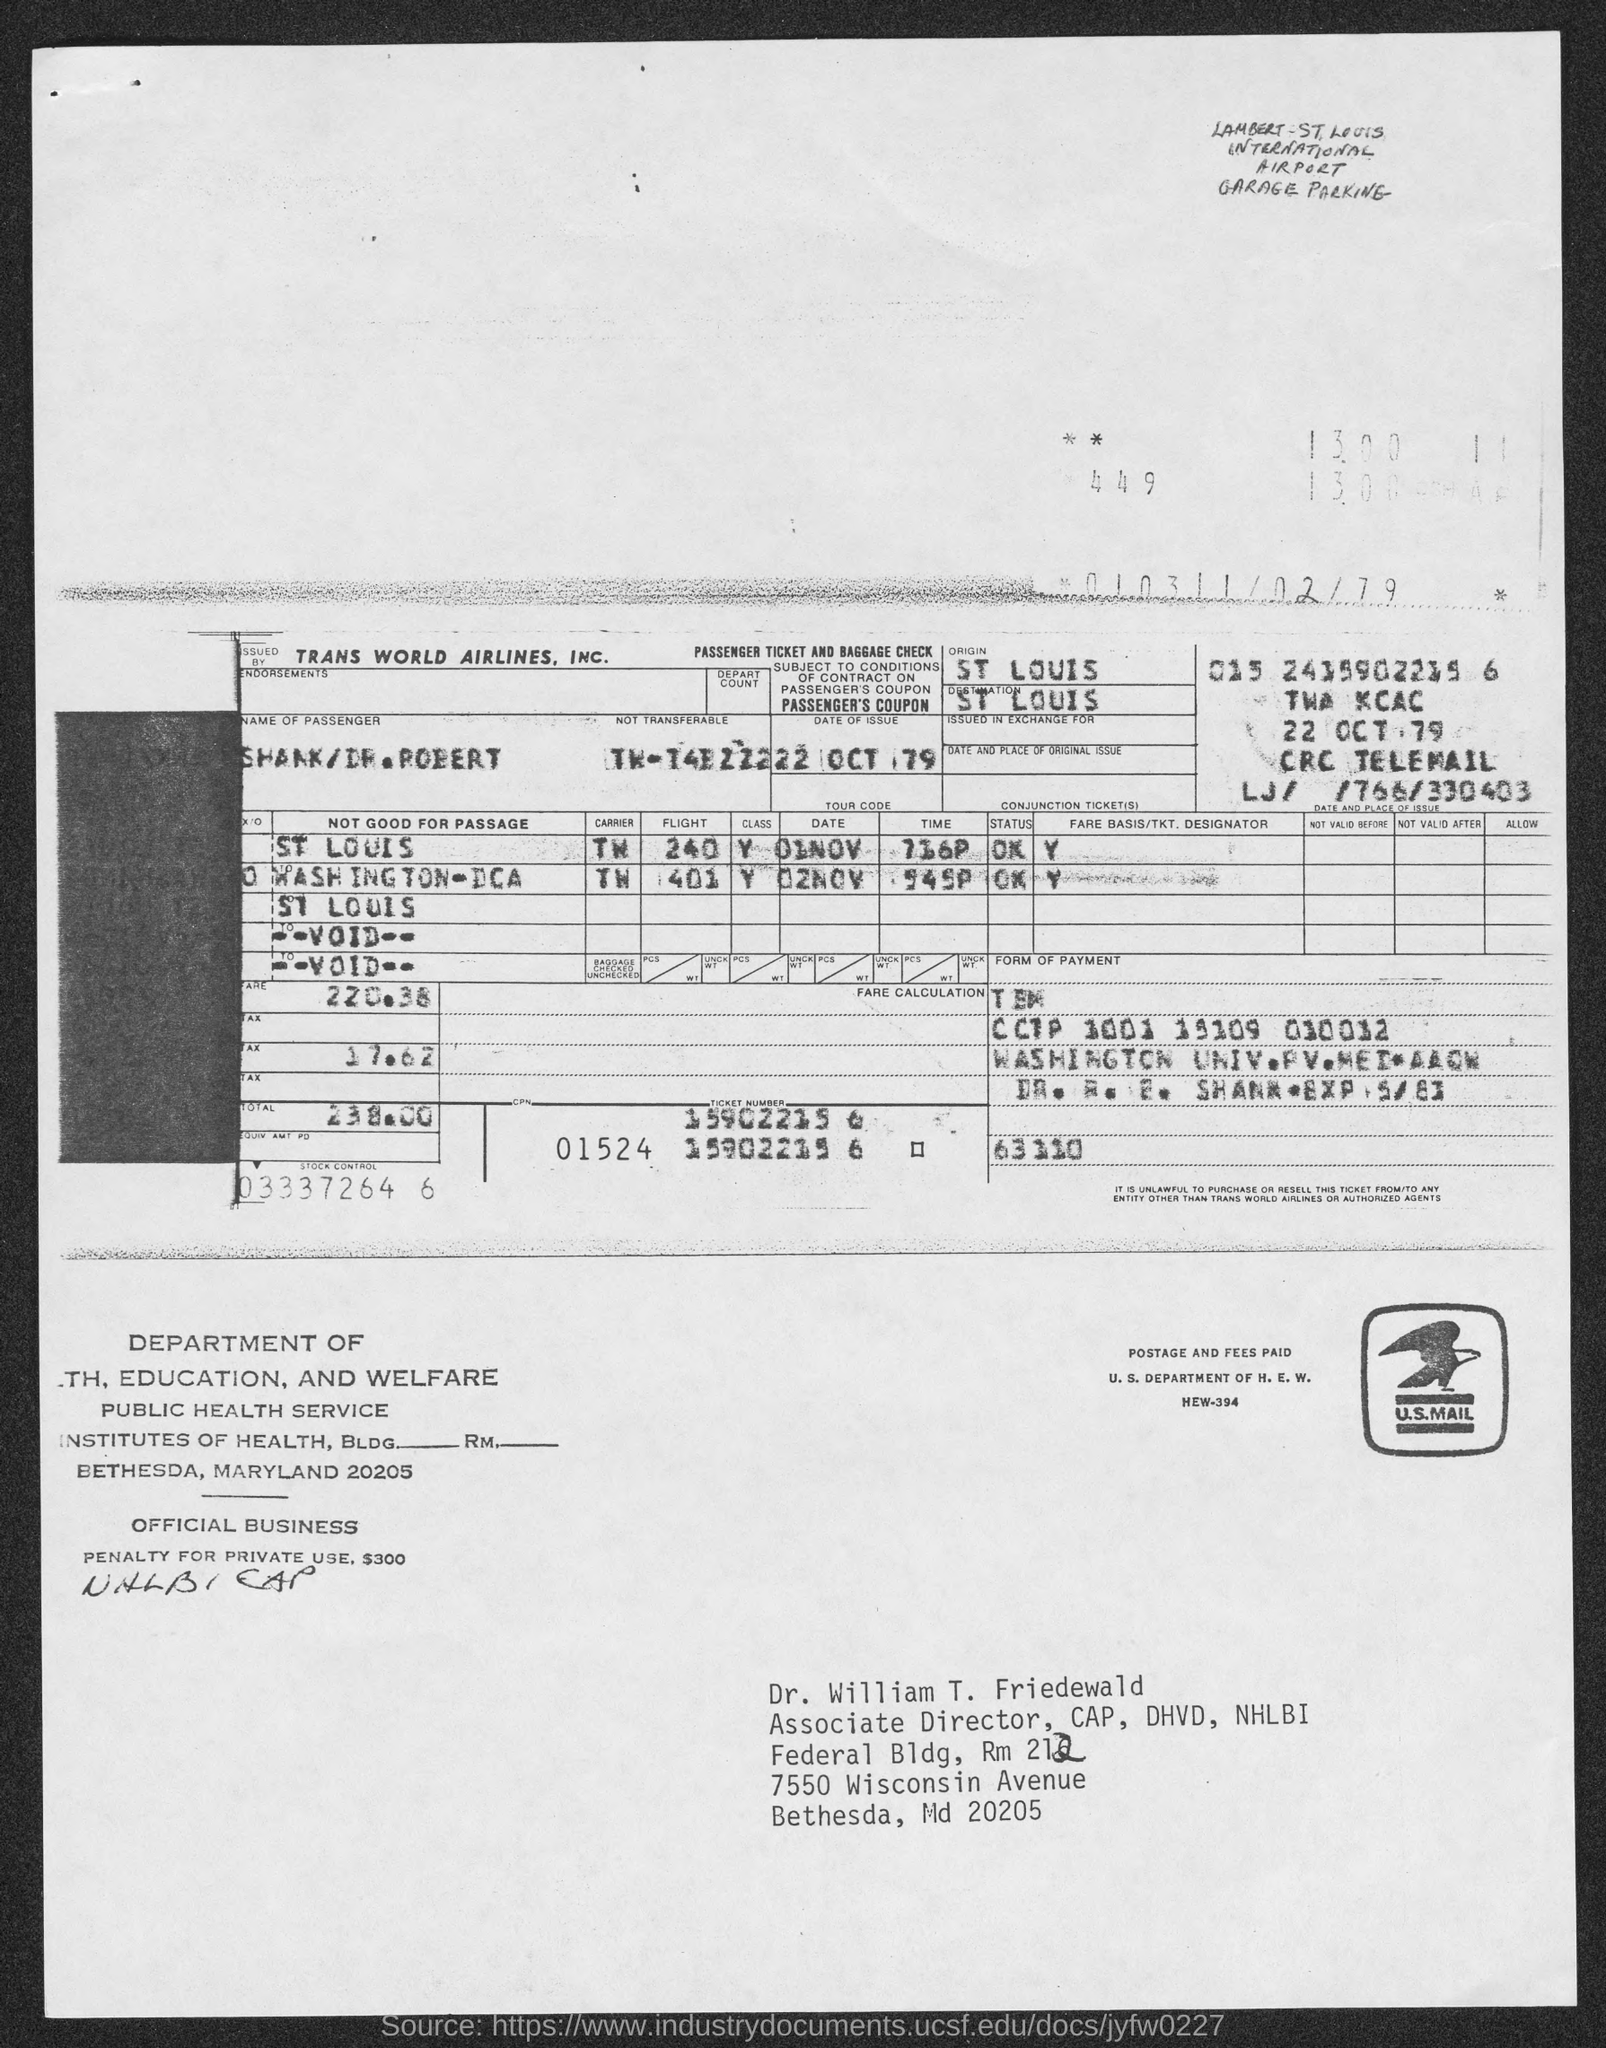What is the origin mentioned in the given form ?
Provide a succinct answer. St louis. What is the destination mentioned in the given form ?
Give a very brief answer. St louis. What is the amount of fare mentioned in the given form ?
Give a very brief answer. 220.38. What is the amount of tax mentioned in the given form ?
Make the answer very short. 17.62. What is the total amount mentioned in the given form ?
Provide a succinct answer. 238.00. 